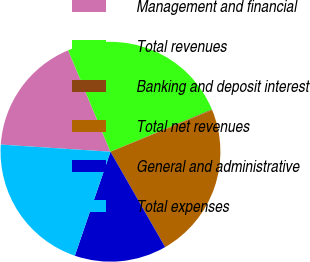<chart> <loc_0><loc_0><loc_500><loc_500><pie_chart><fcel>Management and financial<fcel>Total revenues<fcel>Banking and deposit interest<fcel>Total net revenues<fcel>General and administrative<fcel>Total expenses<nl><fcel>17.67%<fcel>25.01%<fcel>0.11%<fcel>22.89%<fcel>13.54%<fcel>20.78%<nl></chart> 